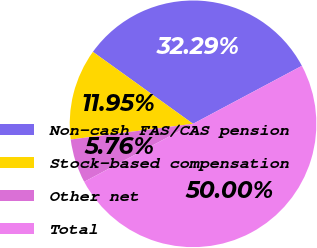Convert chart to OTSL. <chart><loc_0><loc_0><loc_500><loc_500><pie_chart><fcel>Non-cash FAS/CAS pension<fcel>Stock-based compensation<fcel>Other net<fcel>Total<nl><fcel>32.29%<fcel>11.95%<fcel>5.76%<fcel>50.0%<nl></chart> 